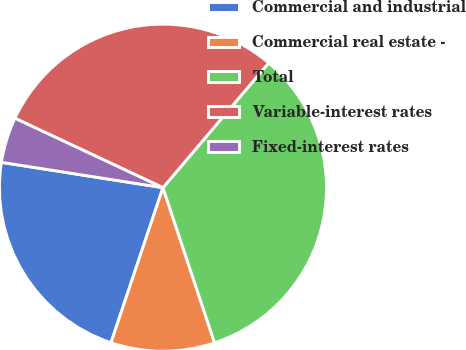<chart> <loc_0><loc_0><loc_500><loc_500><pie_chart><fcel>Commercial and industrial<fcel>Commercial real estate -<fcel>Total<fcel>Variable-interest rates<fcel>Fixed-interest rates<nl><fcel>22.33%<fcel>10.26%<fcel>33.7%<fcel>29.21%<fcel>4.5%<nl></chart> 